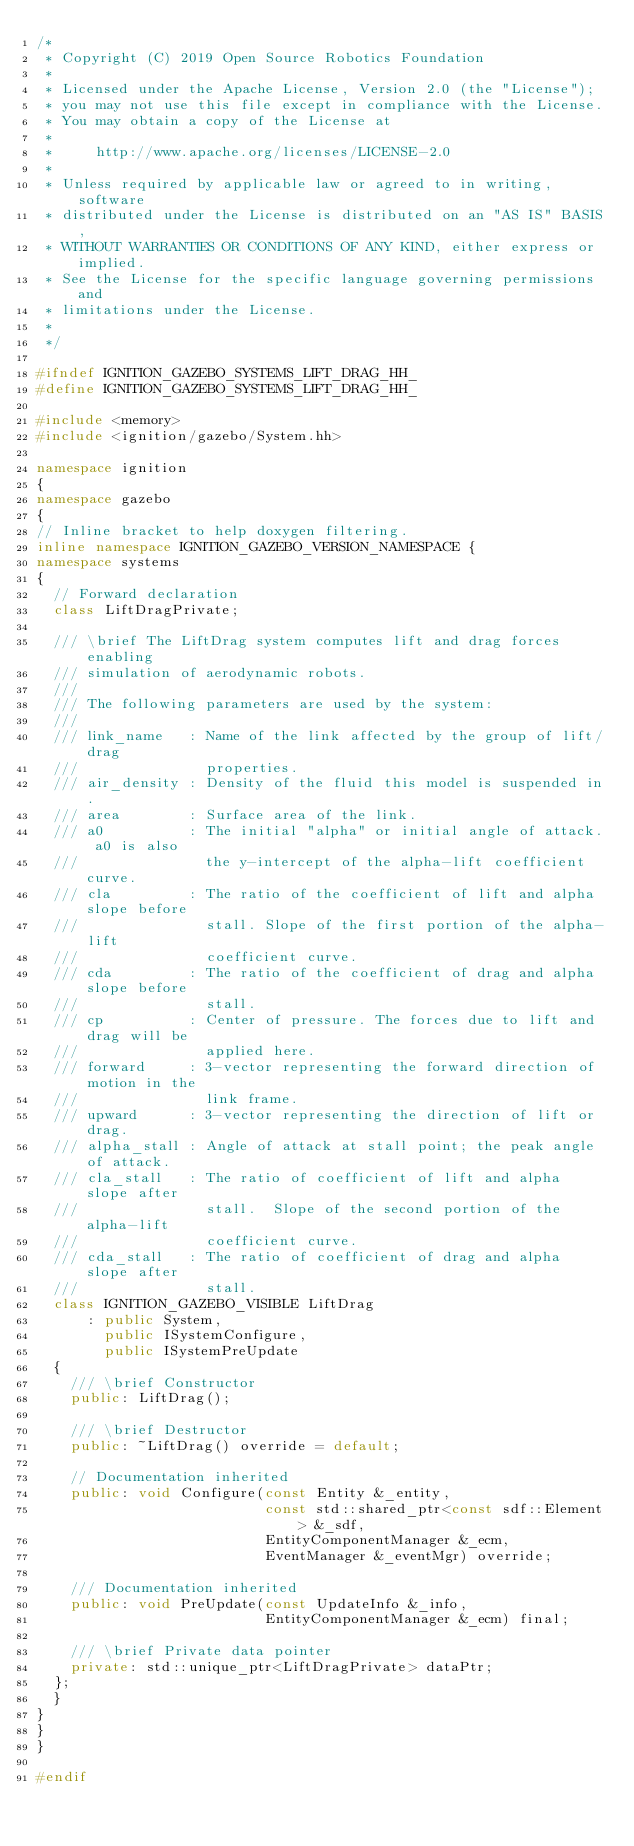<code> <loc_0><loc_0><loc_500><loc_500><_C++_>/*
 * Copyright (C) 2019 Open Source Robotics Foundation
 *
 * Licensed under the Apache License, Version 2.0 (the "License");
 * you may not use this file except in compliance with the License.
 * You may obtain a copy of the License at
 *
 *     http://www.apache.org/licenses/LICENSE-2.0
 *
 * Unless required by applicable law or agreed to in writing, software
 * distributed under the License is distributed on an "AS IS" BASIS,
 * WITHOUT WARRANTIES OR CONDITIONS OF ANY KIND, either express or implied.
 * See the License for the specific language governing permissions and
 * limitations under the License.
 *
 */

#ifndef IGNITION_GAZEBO_SYSTEMS_LIFT_DRAG_HH_
#define IGNITION_GAZEBO_SYSTEMS_LIFT_DRAG_HH_

#include <memory>
#include <ignition/gazebo/System.hh>

namespace ignition
{
namespace gazebo
{
// Inline bracket to help doxygen filtering.
inline namespace IGNITION_GAZEBO_VERSION_NAMESPACE {
namespace systems
{
  // Forward declaration
  class LiftDragPrivate;

  /// \brief The LiftDrag system computes lift and drag forces enabling
  /// simulation of aerodynamic robots.
  ///
  /// The following parameters are used by the system:
  ///
  /// link_name   : Name of the link affected by the group of lift/drag
  ///               properties.
  /// air_density : Density of the fluid this model is suspended in.
  /// area        : Surface area of the link.
  /// a0          : The initial "alpha" or initial angle of attack. a0 is also
  ///               the y-intercept of the alpha-lift coefficient curve.
  /// cla         : The ratio of the coefficient of lift and alpha slope before
  ///               stall. Slope of the first portion of the alpha-lift
  ///               coefficient curve.
  /// cda         : The ratio of the coefficient of drag and alpha slope before
  ///               stall.
  /// cp          : Center of pressure. The forces due to lift and drag will be
  ///               applied here.
  /// forward     : 3-vector representing the forward direction of motion in the
  ///               link frame.
  /// upward      : 3-vector representing the direction of lift or drag.
  /// alpha_stall : Angle of attack at stall point; the peak angle of attack.
  /// cla_stall   : The ratio of coefficient of lift and alpha slope after
  ///               stall.  Slope of the second portion of the alpha-lift
  ///               coefficient curve.
  /// cda_stall   : The ratio of coefficient of drag and alpha slope after
  ///               stall.
  class IGNITION_GAZEBO_VISIBLE LiftDrag
      : public System,
        public ISystemConfigure,
        public ISystemPreUpdate
  {
    /// \brief Constructor
    public: LiftDrag();

    /// \brief Destructor
    public: ~LiftDrag() override = default;

    // Documentation inherited
    public: void Configure(const Entity &_entity,
                           const std::shared_ptr<const sdf::Element> &_sdf,
                           EntityComponentManager &_ecm,
                           EventManager &_eventMgr) override;

    /// Documentation inherited
    public: void PreUpdate(const UpdateInfo &_info,
                           EntityComponentManager &_ecm) final;

    /// \brief Private data pointer
    private: std::unique_ptr<LiftDragPrivate> dataPtr;
  };
  }
}
}
}

#endif

</code> 